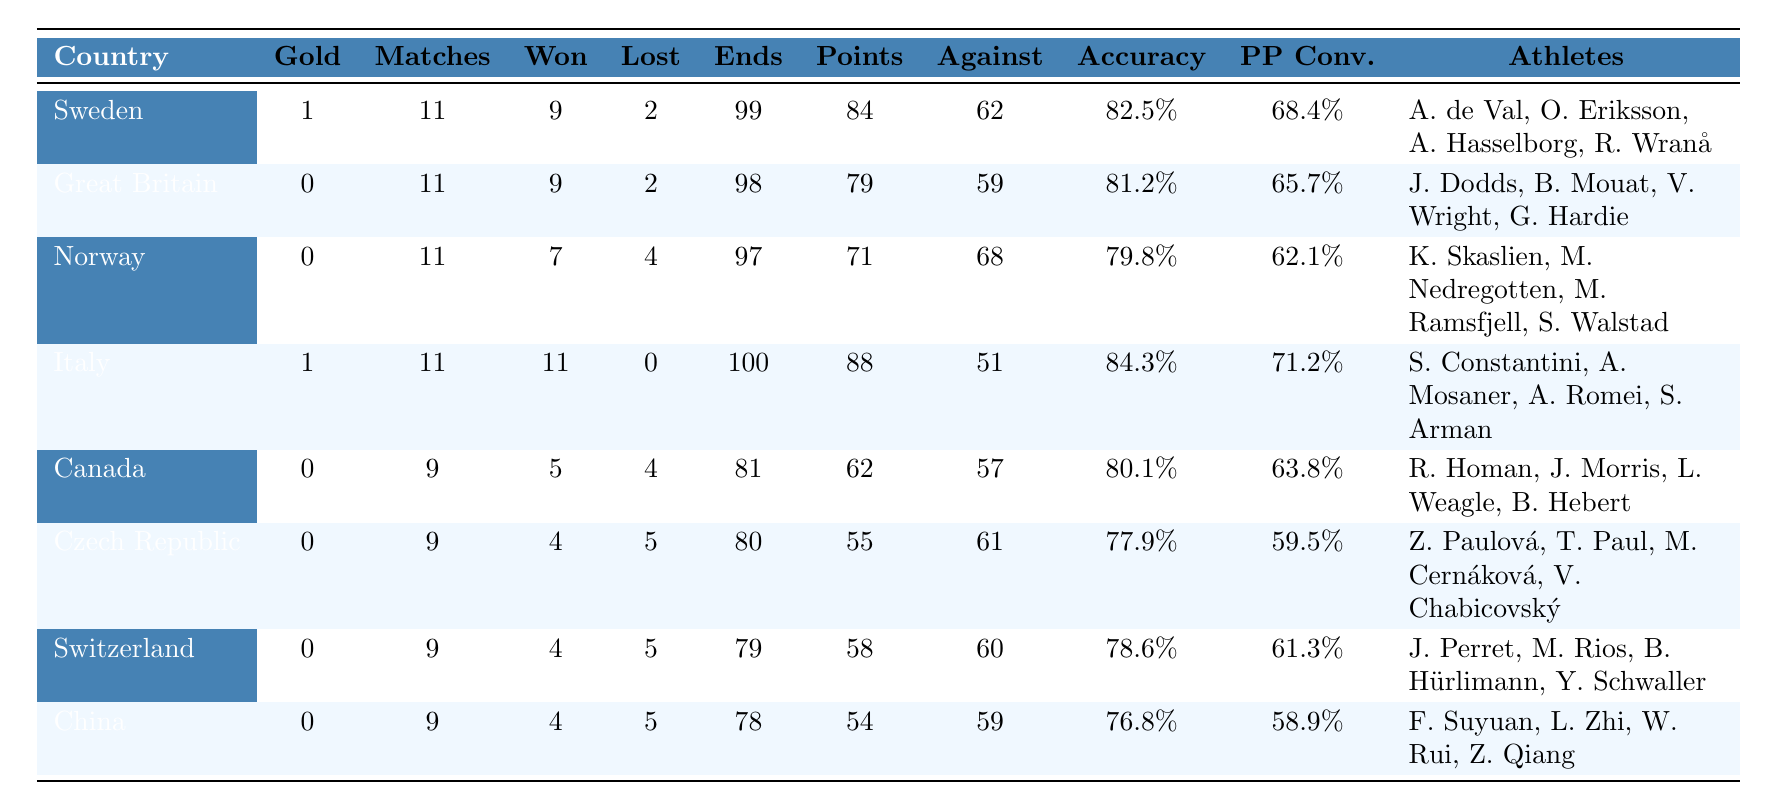What country won the gold medal in mixed curling? According to the table, Sweden and Italy both have gold medals, but Italy has won 1 gold medal while Sweden also has 1. Thus, the country that won the gold medal is identified as Italy.
Answer: Italy How many total matches did Canada play? The table lists Canada with a total of 9 matches played.
Answer: 9 Which team had the highest shooting accuracy percentage? By comparing the shooting accuracy percentages in the table, Italy has the highest at 84.3%.
Answer: Italy What is the total number of matches won by Norway? The table shows that Norway won 7 matches.
Answer: 7 Did Great Britain lose more matches than it won? Great Britain has 9 matches won and 2 lost, meaning they did not lose more matches than they won.
Answer: False Which country had the lowest points scored and what was that score? Looking at the total points scored, China has the lowest at 54 points.
Answer: China, 54 What is the average power play conversion rate for all the teams? Adding the power play conversion rates: 68.4 + 65.7 + 62.1 + 71.2 + 63.8 + 59.5 + 61.3 + 58.9 = 470.9. There are 8 teams, therefore the average is 470.9 / 8 = 58.86%.
Answer: 58.86% Which country had the best record in terms of matches played, won, and lost? By evaluating the matches won and lost, Italy stands out with 11 matches played, 11 won, and 0 lost—making it the best record.
Answer: Italy How many total points were scored by the Czech Republic? The table shows that the Czech Republic scored a total of 55 points.
Answer: 55 If you compare Sweden and Norway, which team had a better total ends played and by how much? Sweden played 99 ends while Norway played 97 ends. The difference is 99 - 97 = 2 ends, making Sweden better by that margin.
Answer: 2 ends Explain whether teams that won gold medals tended to have higher total points scored than teams that did not. Italy and Sweden both have gold medals and scored 88 and 84 points, respectively. Teams without gold (Great Britain, Norway, Canada, Czech Republic, Switzerland, China) scored between 54 and 79 points. Hence, teams with gold medals scored more points on average.
Answer: Yes 